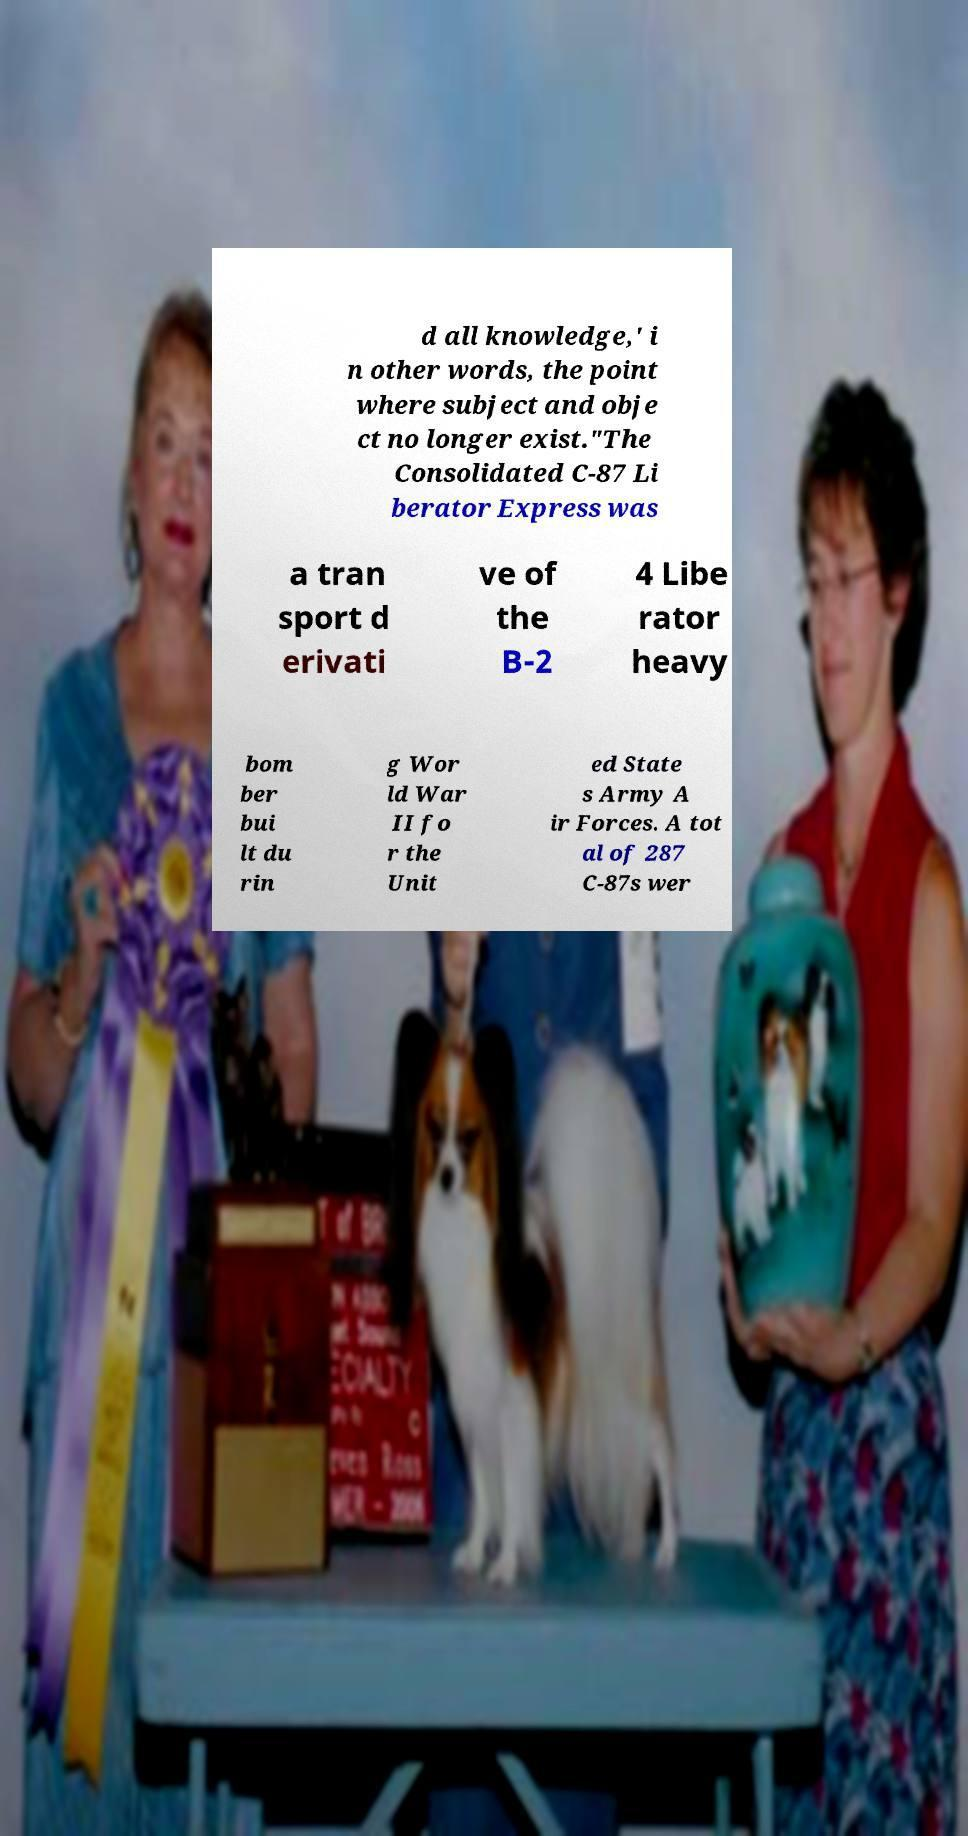Could you assist in decoding the text presented in this image and type it out clearly? d all knowledge,' i n other words, the point where subject and obje ct no longer exist."The Consolidated C-87 Li berator Express was a tran sport d erivati ve of the B-2 4 Libe rator heavy bom ber bui lt du rin g Wor ld War II fo r the Unit ed State s Army A ir Forces. A tot al of 287 C-87s wer 